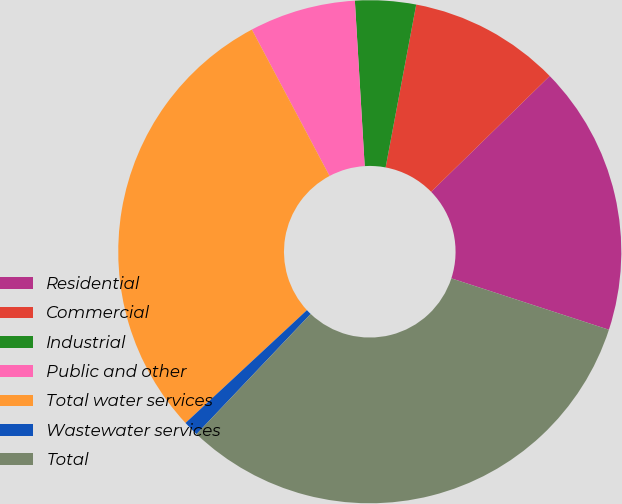Convert chart. <chart><loc_0><loc_0><loc_500><loc_500><pie_chart><fcel>Residential<fcel>Commercial<fcel>Industrial<fcel>Public and other<fcel>Total water services<fcel>Wastewater services<fcel>Total<nl><fcel>17.33%<fcel>9.73%<fcel>3.9%<fcel>6.82%<fcel>29.15%<fcel>0.99%<fcel>32.07%<nl></chart> 